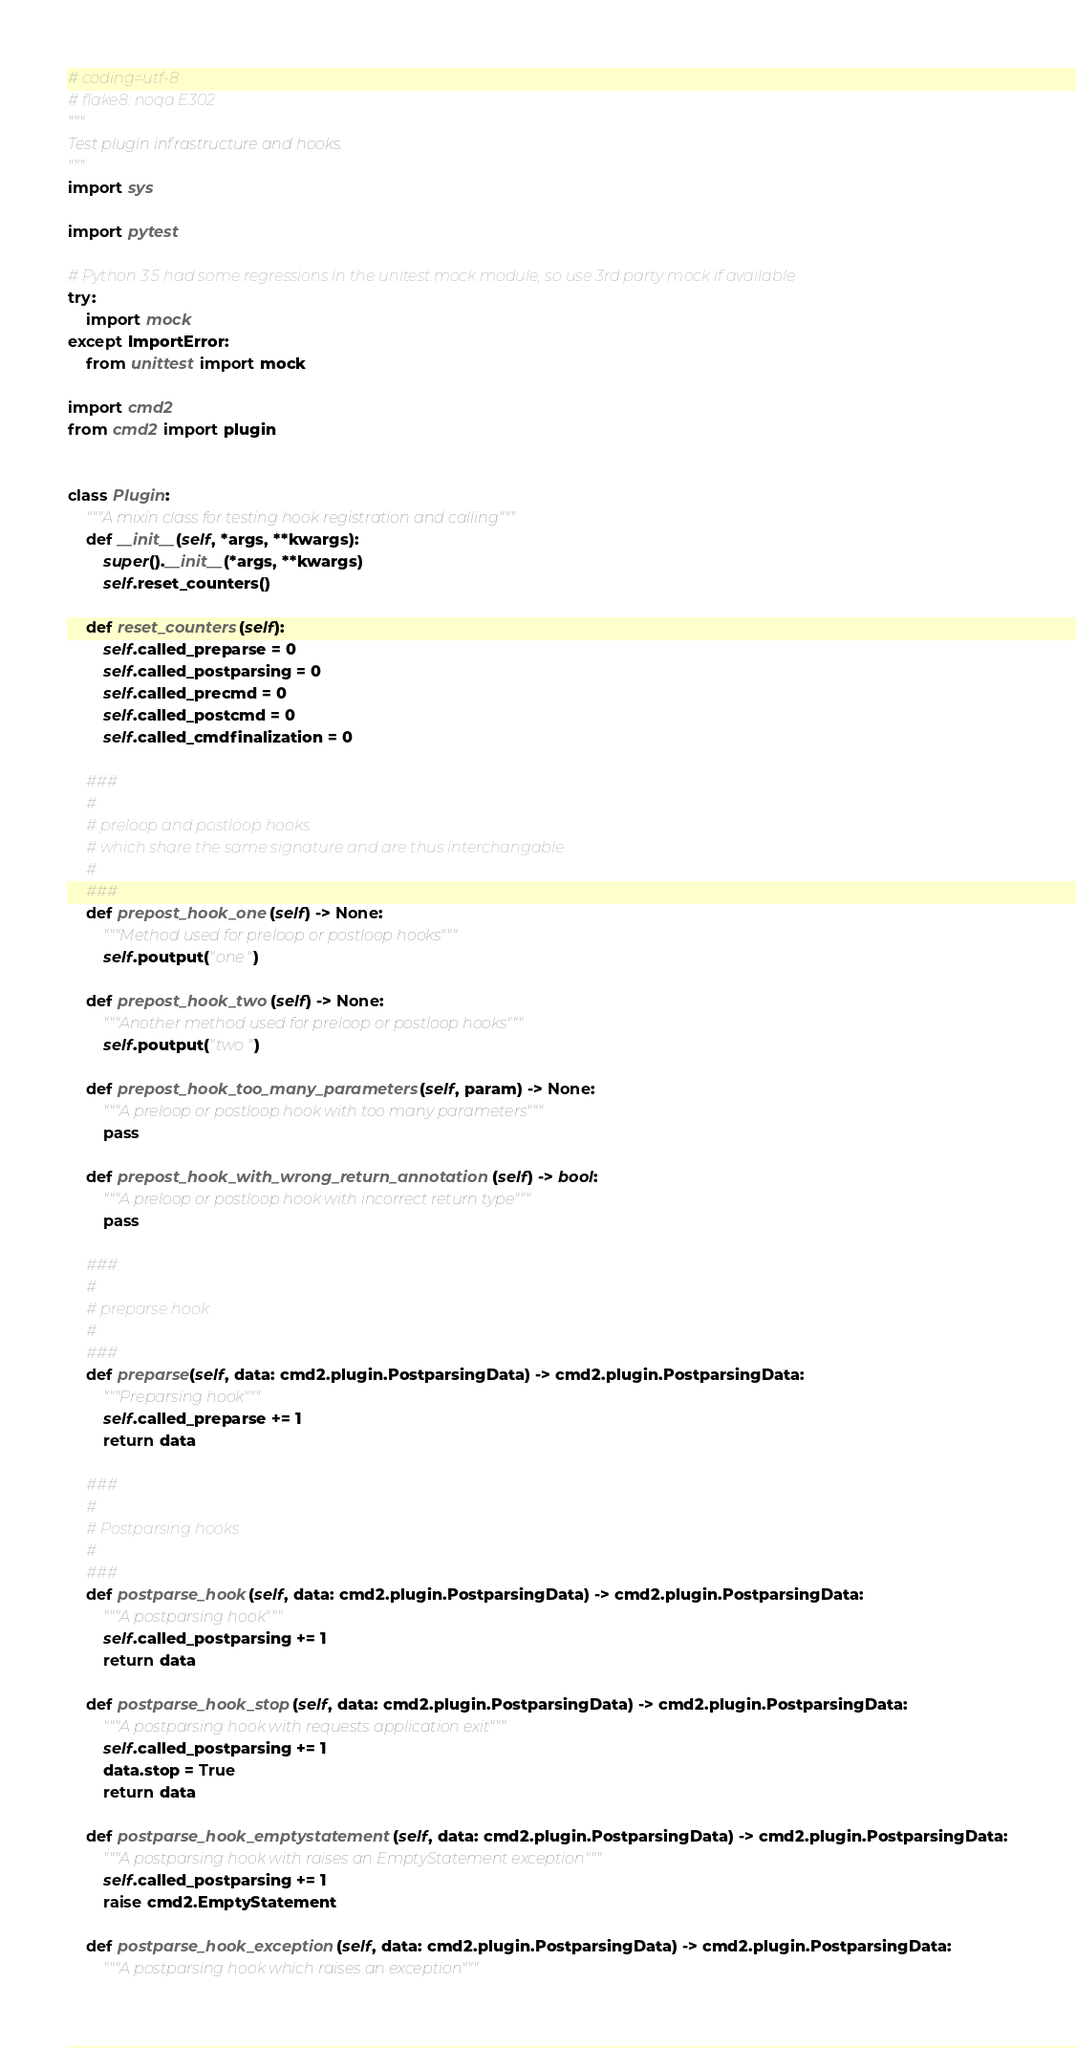<code> <loc_0><loc_0><loc_500><loc_500><_Python_># coding=utf-8
# flake8: noqa E302
"""
Test plugin infrastructure and hooks.
"""
import sys

import pytest

# Python 3.5 had some regressions in the unitest.mock module, so use 3rd party mock if available
try:
    import mock
except ImportError:
    from unittest import mock

import cmd2
from cmd2 import plugin


class Plugin:
    """A mixin class for testing hook registration and calling"""
    def __init__(self, *args, **kwargs):
        super().__init__(*args, **kwargs)
        self.reset_counters()

    def reset_counters(self):
        self.called_preparse = 0
        self.called_postparsing = 0
        self.called_precmd = 0
        self.called_postcmd = 0
        self.called_cmdfinalization = 0

    ###
    #
    # preloop and postloop hooks
    # which share the same signature and are thus interchangable
    #
    ###
    def prepost_hook_one(self) -> None:
        """Method used for preloop or postloop hooks"""
        self.poutput("one")

    def prepost_hook_two(self) -> None:
        """Another method used for preloop or postloop hooks"""
        self.poutput("two")

    def prepost_hook_too_many_parameters(self, param) -> None:
        """A preloop or postloop hook with too many parameters"""
        pass

    def prepost_hook_with_wrong_return_annotation(self) -> bool:
        """A preloop or postloop hook with incorrect return type"""
        pass

    ###
    #
    # preparse hook
    #
    ###
    def preparse(self, data: cmd2.plugin.PostparsingData) -> cmd2.plugin.PostparsingData:
        """Preparsing hook"""
        self.called_preparse += 1
        return data

    ###
    #
    # Postparsing hooks
    #
    ###
    def postparse_hook(self, data: cmd2.plugin.PostparsingData) -> cmd2.plugin.PostparsingData:
        """A postparsing hook"""
        self.called_postparsing += 1
        return data

    def postparse_hook_stop(self, data: cmd2.plugin.PostparsingData) -> cmd2.plugin.PostparsingData:
        """A postparsing hook with requests application exit"""
        self.called_postparsing += 1
        data.stop = True
        return data

    def postparse_hook_emptystatement(self, data: cmd2.plugin.PostparsingData) -> cmd2.plugin.PostparsingData:
        """A postparsing hook with raises an EmptyStatement exception"""
        self.called_postparsing += 1
        raise cmd2.EmptyStatement

    def postparse_hook_exception(self, data: cmd2.plugin.PostparsingData) -> cmd2.plugin.PostparsingData:
        """A postparsing hook which raises an exception"""</code> 